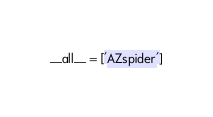Convert code to text. <code><loc_0><loc_0><loc_500><loc_500><_Python_>__all__ = ['AZspider']
</code> 